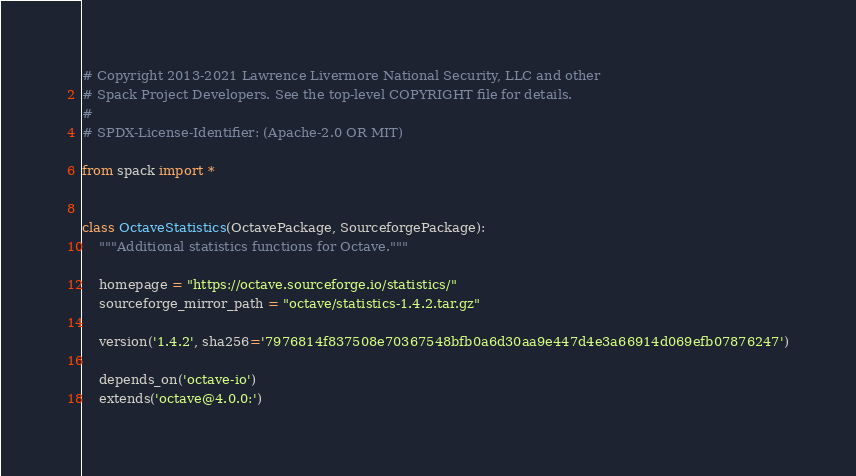<code> <loc_0><loc_0><loc_500><loc_500><_Python_># Copyright 2013-2021 Lawrence Livermore National Security, LLC and other
# Spack Project Developers. See the top-level COPYRIGHT file for details.
#
# SPDX-License-Identifier: (Apache-2.0 OR MIT)

from spack import *


class OctaveStatistics(OctavePackage, SourceforgePackage):
    """Additional statistics functions for Octave."""

    homepage = "https://octave.sourceforge.io/statistics/"
    sourceforge_mirror_path = "octave/statistics-1.4.2.tar.gz"

    version('1.4.2', sha256='7976814f837508e70367548bfb0a6d30aa9e447d4e3a66914d069efb07876247')

    depends_on('octave-io')
    extends('octave@4.0.0:')
</code> 